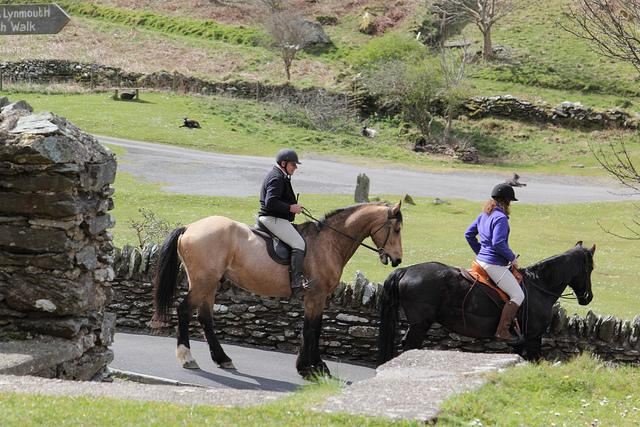What are the black helmets the people are wearing made for?

Choices:
A) halloween
B) style
C) riding
D) sweat reduction riding 